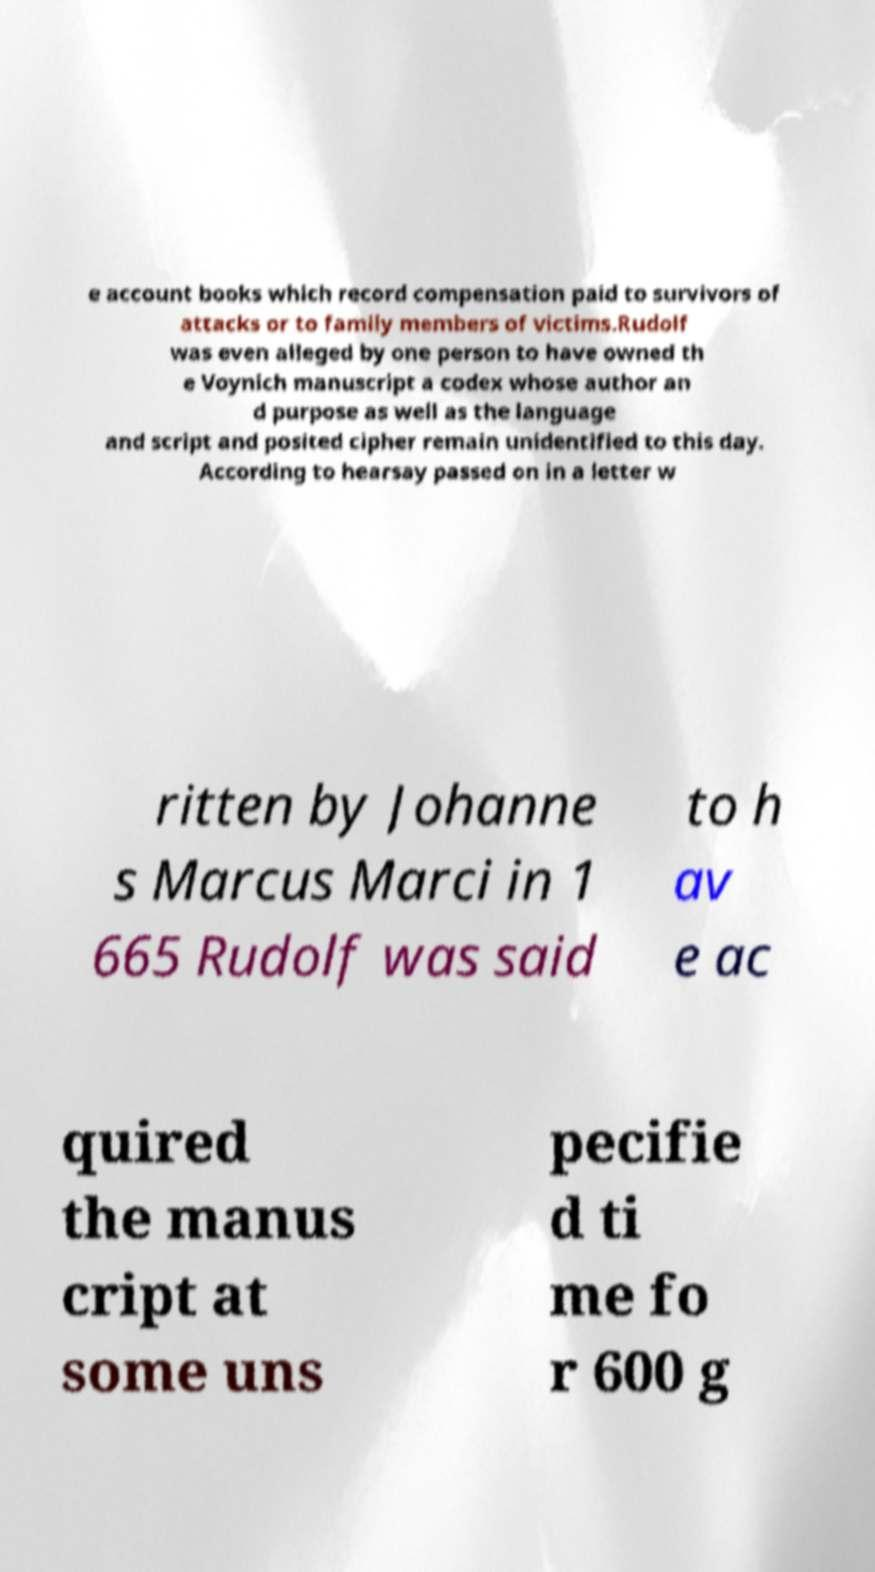Can you read and provide the text displayed in the image?This photo seems to have some interesting text. Can you extract and type it out for me? e account books which record compensation paid to survivors of attacks or to family members of victims.Rudolf was even alleged by one person to have owned th e Voynich manuscript a codex whose author an d purpose as well as the language and script and posited cipher remain unidentified to this day. According to hearsay passed on in a letter w ritten by Johanne s Marcus Marci in 1 665 Rudolf was said to h av e ac quired the manus cript at some uns pecifie d ti me fo r 600 g 